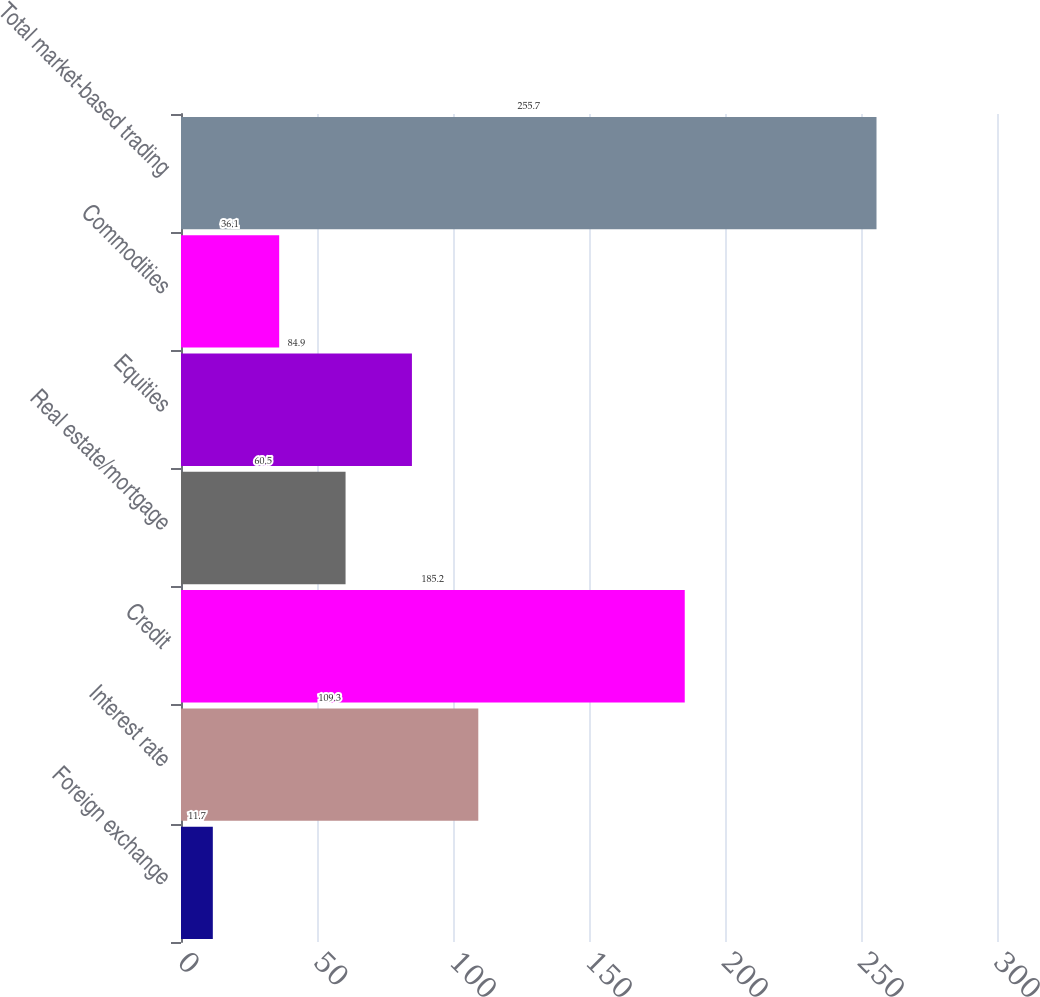Convert chart to OTSL. <chart><loc_0><loc_0><loc_500><loc_500><bar_chart><fcel>Foreign exchange<fcel>Interest rate<fcel>Credit<fcel>Real estate/mortgage<fcel>Equities<fcel>Commodities<fcel>Total market-based trading<nl><fcel>11.7<fcel>109.3<fcel>185.2<fcel>60.5<fcel>84.9<fcel>36.1<fcel>255.7<nl></chart> 